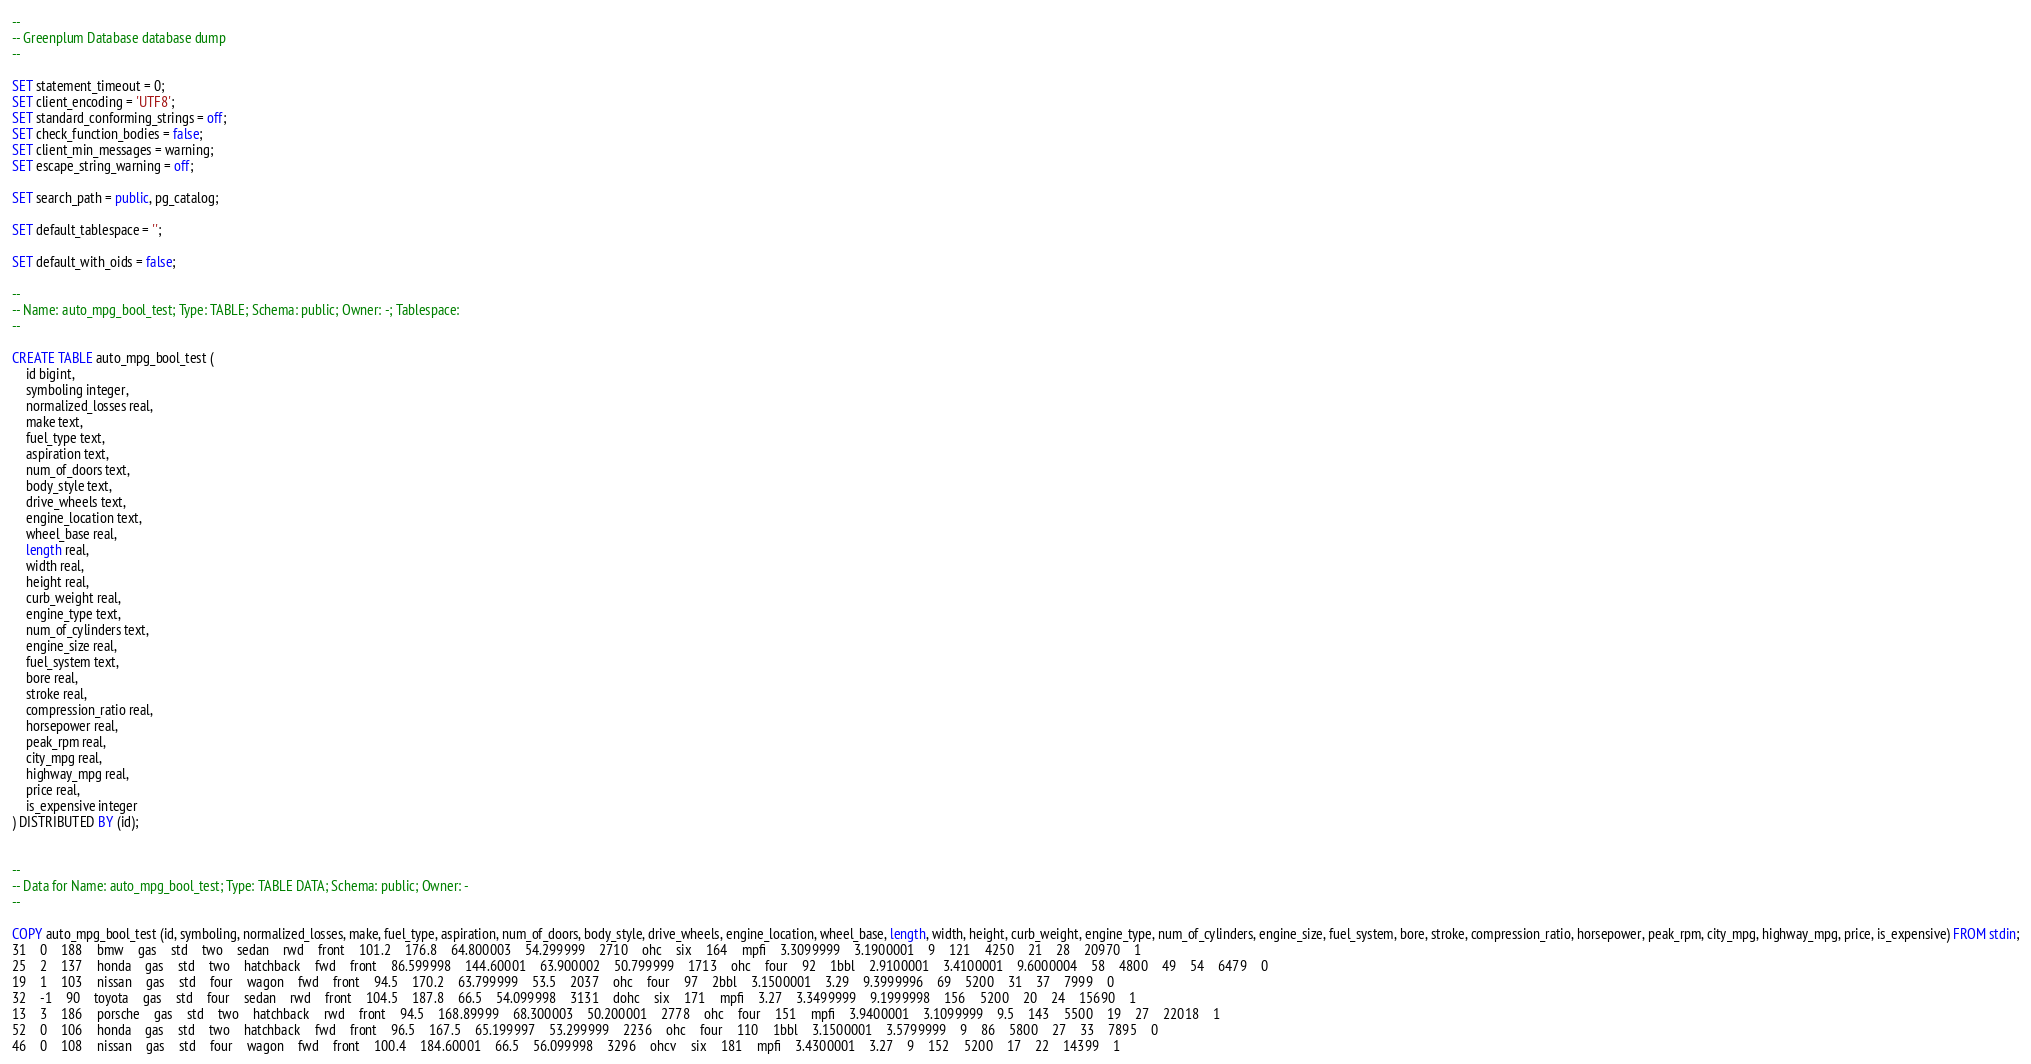Convert code to text. <code><loc_0><loc_0><loc_500><loc_500><_SQL_>--
-- Greenplum Database database dump
--

SET statement_timeout = 0;
SET client_encoding = 'UTF8';
SET standard_conforming_strings = off;
SET check_function_bodies = false;
SET client_min_messages = warning;
SET escape_string_warning = off;

SET search_path = public, pg_catalog;

SET default_tablespace = '';

SET default_with_oids = false;

--
-- Name: auto_mpg_bool_test; Type: TABLE; Schema: public; Owner: -; Tablespace: 
--

CREATE TABLE auto_mpg_bool_test (
    id bigint,
    symboling integer,
    normalized_losses real,
    make text,
    fuel_type text,
    aspiration text,
    num_of_doors text,
    body_style text,
    drive_wheels text,
    engine_location text,
    wheel_base real,
    length real,
    width real,
    height real,
    curb_weight real,
    engine_type text,
    num_of_cylinders text,
    engine_size real,
    fuel_system text,
    bore real,
    stroke real,
    compression_ratio real,
    horsepower real,
    peak_rpm real,
    city_mpg real,
    highway_mpg real,
    price real,
    is_expensive integer
) DISTRIBUTED BY (id);


--
-- Data for Name: auto_mpg_bool_test; Type: TABLE DATA; Schema: public; Owner: -
--

COPY auto_mpg_bool_test (id, symboling, normalized_losses, make, fuel_type, aspiration, num_of_doors, body_style, drive_wheels, engine_location, wheel_base, length, width, height, curb_weight, engine_type, num_of_cylinders, engine_size, fuel_system, bore, stroke, compression_ratio, horsepower, peak_rpm, city_mpg, highway_mpg, price, is_expensive) FROM stdin;
31	0	188	bmw	gas	std	two	sedan	rwd	front	101.2	176.8	64.800003	54.299999	2710	ohc	six	164	mpfi	3.3099999	3.1900001	9	121	4250	21	28	20970	1
25	2	137	honda	gas	std	two	hatchback	fwd	front	86.599998	144.60001	63.900002	50.799999	1713	ohc	four	92	1bbl	2.9100001	3.4100001	9.6000004	58	4800	49	54	6479	0
19	1	103	nissan	gas	std	four	wagon	fwd	front	94.5	170.2	63.799999	53.5	2037	ohc	four	97	2bbl	3.1500001	3.29	9.3999996	69	5200	31	37	7999	0
32	-1	90	toyota	gas	std	four	sedan	rwd	front	104.5	187.8	66.5	54.099998	3131	dohc	six	171	mpfi	3.27	3.3499999	9.1999998	156	5200	20	24	15690	1
13	3	186	porsche	gas	std	two	hatchback	rwd	front	94.5	168.89999	68.300003	50.200001	2778	ohc	four	151	mpfi	3.9400001	3.1099999	9.5	143	5500	19	27	22018	1
52	0	106	honda	gas	std	two	hatchback	fwd	front	96.5	167.5	65.199997	53.299999	2236	ohc	four	110	1bbl	3.1500001	3.5799999	9	86	5800	27	33	7895	0
46	0	108	nissan	gas	std	four	wagon	fwd	front	100.4	184.60001	66.5	56.099998	3296	ohcv	six	181	mpfi	3.4300001	3.27	9	152	5200	17	22	14399	1</code> 